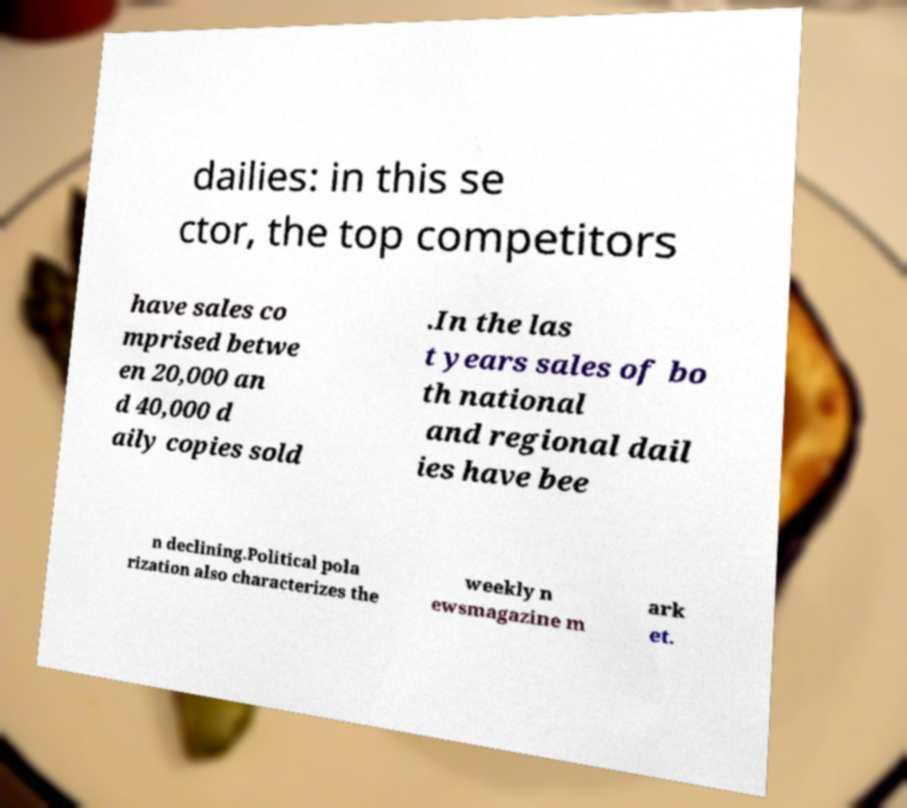What messages or text are displayed in this image? I need them in a readable, typed format. dailies: in this se ctor, the top competitors have sales co mprised betwe en 20,000 an d 40,000 d aily copies sold .In the las t years sales of bo th national and regional dail ies have bee n declining.Political pola rization also characterizes the weekly n ewsmagazine m ark et. 